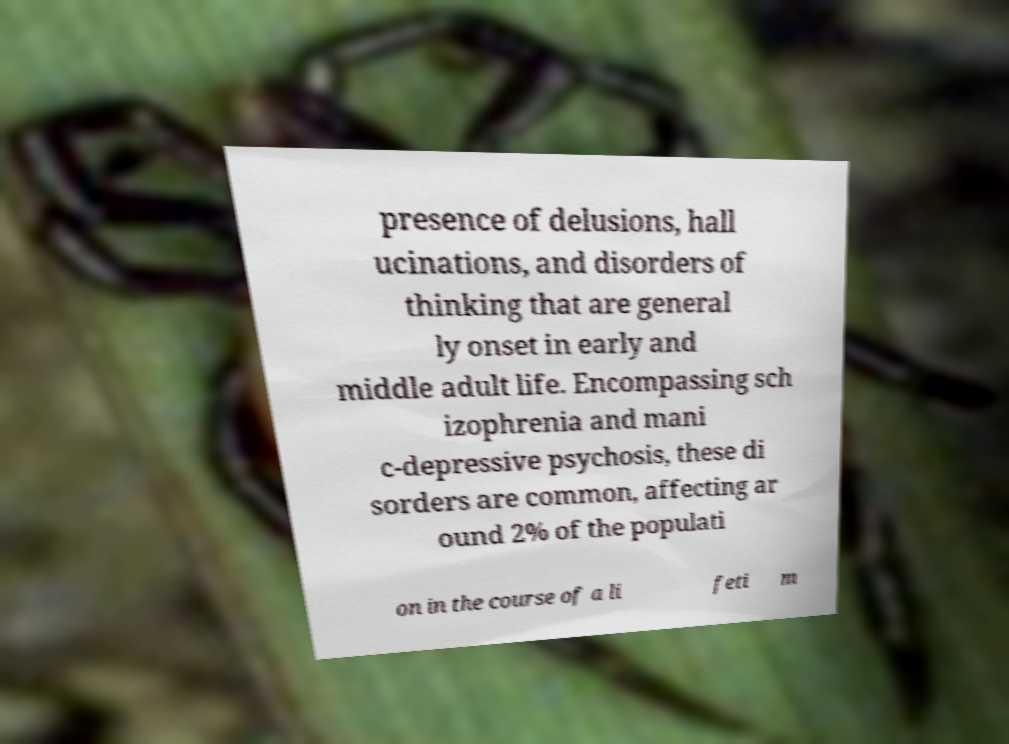I need the written content from this picture converted into text. Can you do that? presence of delusions, hall ucinations, and disorders of thinking that are general ly onset in early and middle adult life. Encompassing sch izophrenia and mani c-depressive psychosis, these di sorders are common, affecting ar ound 2% of the populati on in the course of a li feti m 